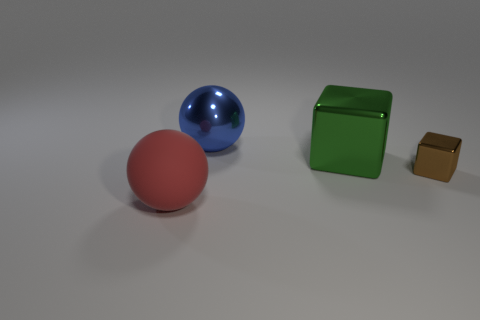What material is the other object that is the same shape as the blue metallic object?
Offer a terse response. Rubber. Are any large yellow things visible?
Give a very brief answer. No. The other blue thing that is the same material as the tiny object is what shape?
Provide a short and direct response. Sphere. There is a sphere in front of the big cube; what is it made of?
Offer a terse response. Rubber. What size is the ball behind the large ball in front of the big shiny sphere?
Provide a short and direct response. Large. Is the number of large objects behind the brown object greater than the number of blue spheres?
Ensure brevity in your answer.  Yes. Does the block that is behind the brown cube have the same size as the big blue object?
Your answer should be compact. Yes. The big object that is both behind the tiny brown shiny cube and to the left of the green shiny block is what color?
Offer a very short reply. Blue. What shape is the matte thing that is the same size as the blue ball?
Provide a succinct answer. Sphere. Are there the same number of things behind the big red object and shiny objects?
Keep it short and to the point. Yes. 